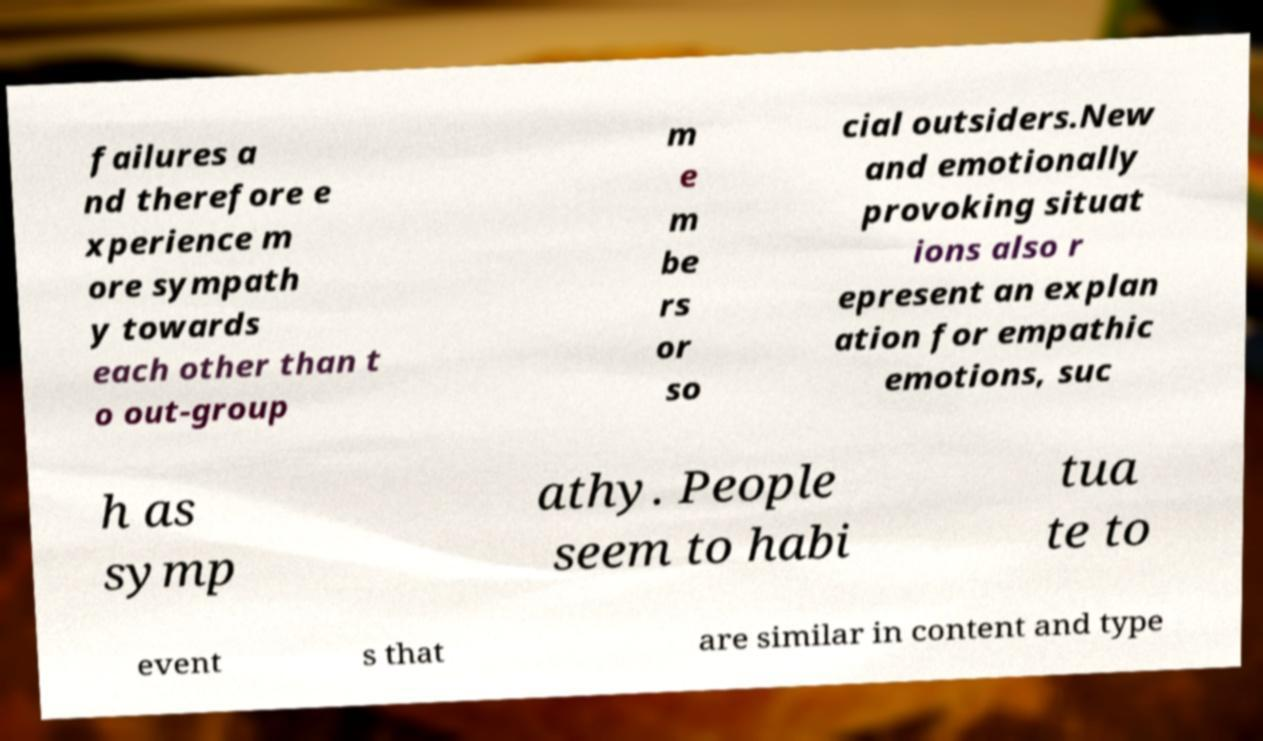Could you assist in decoding the text presented in this image and type it out clearly? failures a nd therefore e xperience m ore sympath y towards each other than t o out-group m e m be rs or so cial outsiders.New and emotionally provoking situat ions also r epresent an explan ation for empathic emotions, suc h as symp athy. People seem to habi tua te to event s that are similar in content and type 